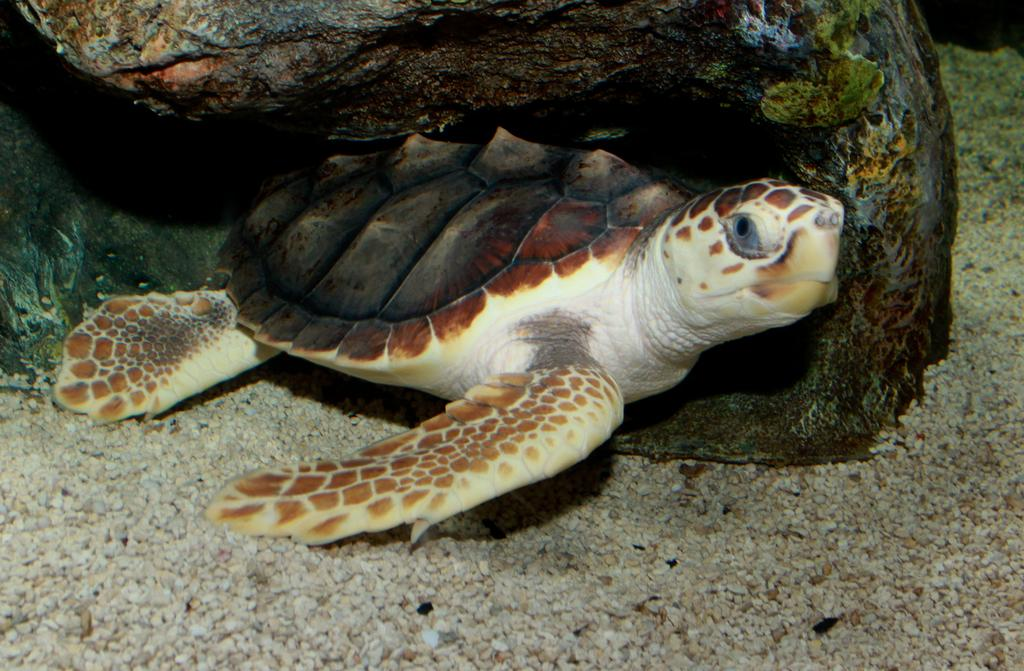What type of animal is in the image? There is a sea turtle in the image. Where is the sea turtle located? The sea turtle is underwater. What other objects can be seen in the image? There are stones and a rock in the image. What type of clouds can be seen in the image? There are no clouds present in the image, as it is underwater and focused on a sea turtle and surrounding objects. 